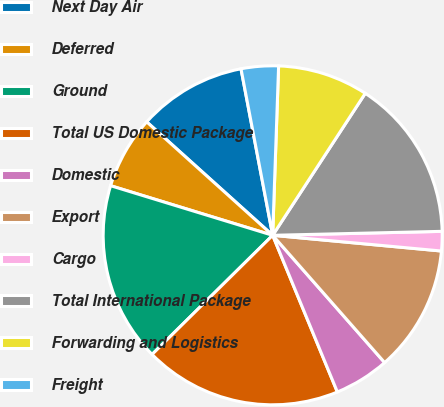Convert chart to OTSL. <chart><loc_0><loc_0><loc_500><loc_500><pie_chart><fcel>Next Day Air<fcel>Deferred<fcel>Ground<fcel>Total US Domestic Package<fcel>Domestic<fcel>Export<fcel>Cargo<fcel>Total International Package<fcel>Forwarding and Logistics<fcel>Freight<nl><fcel>10.34%<fcel>6.94%<fcel>17.13%<fcel>18.83%<fcel>5.25%<fcel>12.04%<fcel>1.85%<fcel>15.43%<fcel>8.64%<fcel>3.55%<nl></chart> 